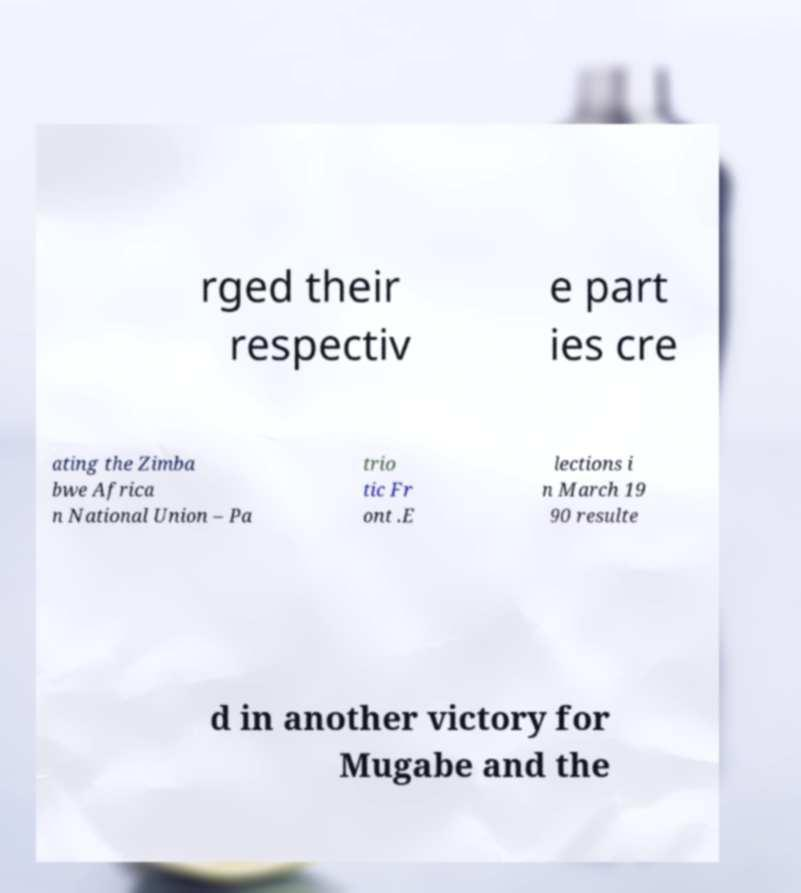Could you extract and type out the text from this image? rged their respectiv e part ies cre ating the Zimba bwe Africa n National Union – Pa trio tic Fr ont .E lections i n March 19 90 resulte d in another victory for Mugabe and the 